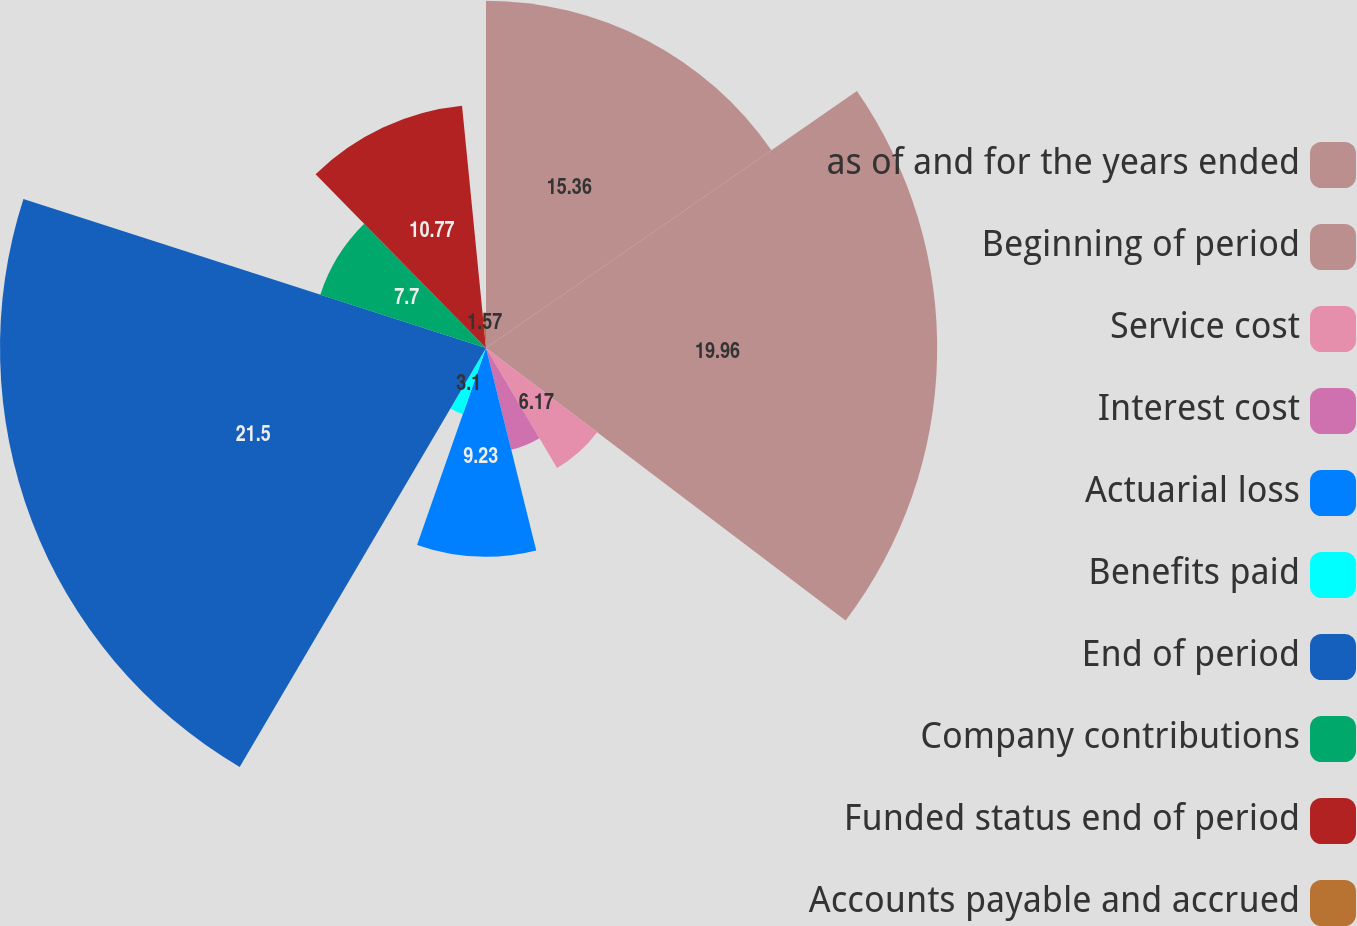<chart> <loc_0><loc_0><loc_500><loc_500><pie_chart><fcel>as of and for the years ended<fcel>Beginning of period<fcel>Service cost<fcel>Interest cost<fcel>Actuarial loss<fcel>Benefits paid<fcel>End of period<fcel>Company contributions<fcel>Funded status end of period<fcel>Accounts payable and accrued<nl><fcel>15.36%<fcel>19.96%<fcel>6.17%<fcel>4.64%<fcel>9.23%<fcel>3.1%<fcel>21.5%<fcel>7.7%<fcel>10.77%<fcel>1.57%<nl></chart> 